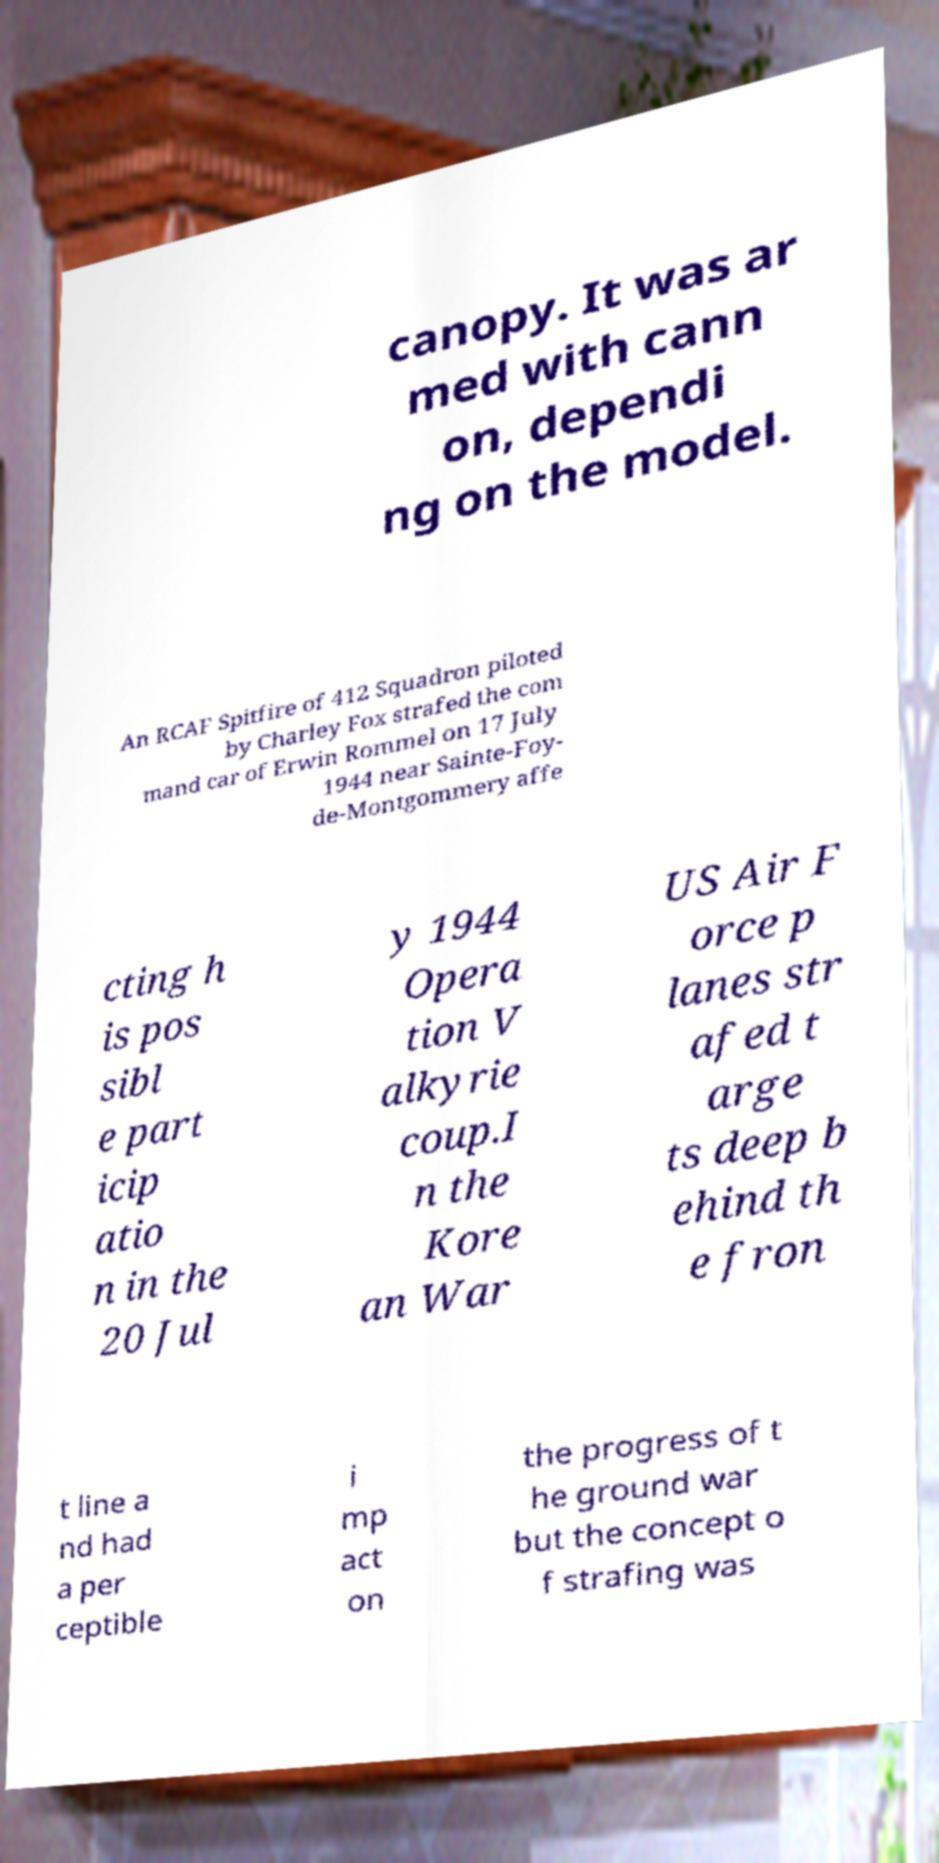For documentation purposes, I need the text within this image transcribed. Could you provide that? canopy. It was ar med with cann on, dependi ng on the model. An RCAF Spitfire of 412 Squadron piloted by Charley Fox strafed the com mand car of Erwin Rommel on 17 July 1944 near Sainte-Foy- de-Montgommery affe cting h is pos sibl e part icip atio n in the 20 Jul y 1944 Opera tion V alkyrie coup.I n the Kore an War US Air F orce p lanes str afed t arge ts deep b ehind th e fron t line a nd had a per ceptible i mp act on the progress of t he ground war but the concept o f strafing was 